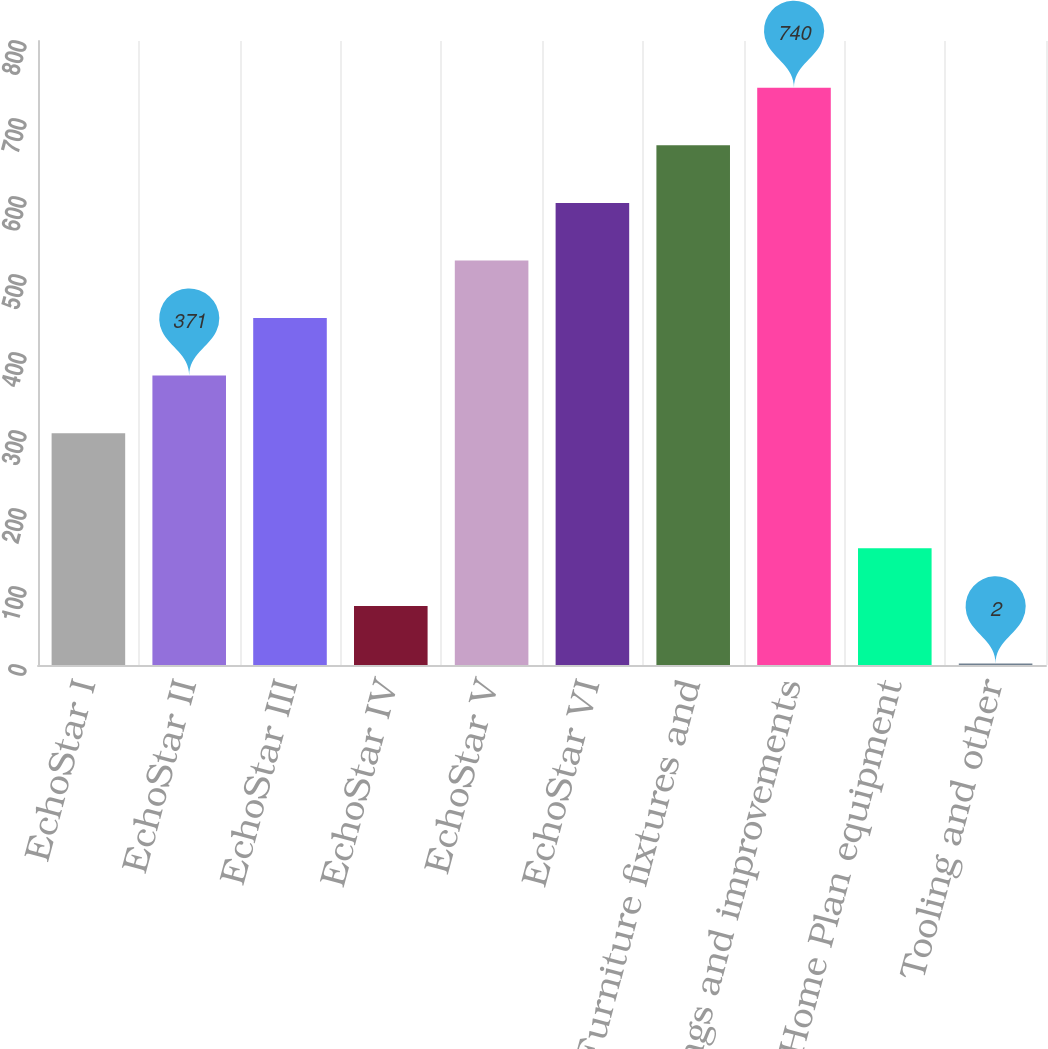Convert chart. <chart><loc_0><loc_0><loc_500><loc_500><bar_chart><fcel>EchoStar I<fcel>EchoStar II<fcel>EchoStar III<fcel>EchoStar IV<fcel>EchoStar V<fcel>EchoStar VI<fcel>Furniture fixtures and<fcel>Buildings and improvements<fcel>Digital Home Plan equipment<fcel>Tooling and other<nl><fcel>297.2<fcel>371<fcel>444.8<fcel>75.8<fcel>518.6<fcel>592.4<fcel>666.2<fcel>740<fcel>149.6<fcel>2<nl></chart> 